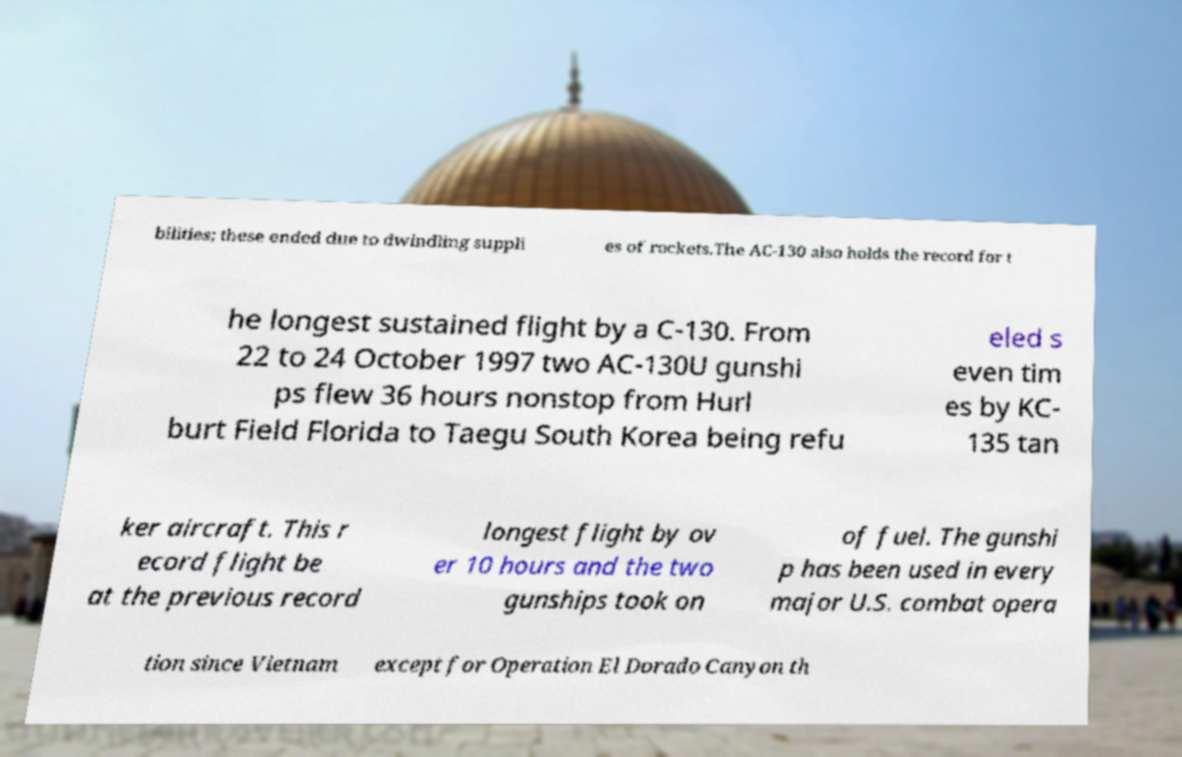For documentation purposes, I need the text within this image transcribed. Could you provide that? bilities; these ended due to dwindling suppli es of rockets.The AC-130 also holds the record for t he longest sustained flight by a C-130. From 22 to 24 October 1997 two AC-130U gunshi ps flew 36 hours nonstop from Hurl burt Field Florida to Taegu South Korea being refu eled s even tim es by KC- 135 tan ker aircraft. This r ecord flight be at the previous record longest flight by ov er 10 hours and the two gunships took on of fuel. The gunshi p has been used in every major U.S. combat opera tion since Vietnam except for Operation El Dorado Canyon th 